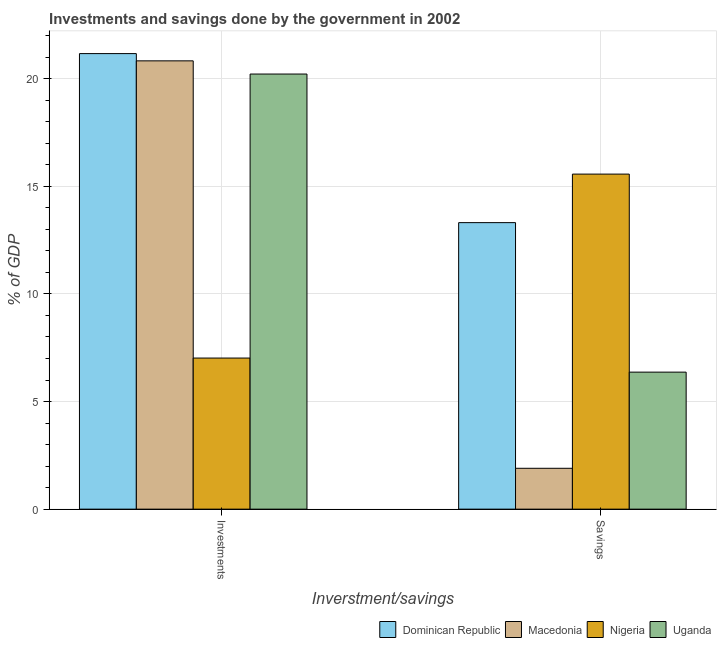How many different coloured bars are there?
Your response must be concise. 4. How many groups of bars are there?
Your answer should be compact. 2. Are the number of bars per tick equal to the number of legend labels?
Make the answer very short. Yes. How many bars are there on the 2nd tick from the right?
Provide a succinct answer. 4. What is the label of the 1st group of bars from the left?
Give a very brief answer. Investments. What is the investments of government in Dominican Republic?
Your response must be concise. 21.17. Across all countries, what is the maximum investments of government?
Make the answer very short. 21.17. Across all countries, what is the minimum investments of government?
Keep it short and to the point. 7.02. In which country was the savings of government maximum?
Your response must be concise. Nigeria. In which country was the savings of government minimum?
Keep it short and to the point. Macedonia. What is the total investments of government in the graph?
Keep it short and to the point. 69.24. What is the difference between the savings of government in Nigeria and that in Uganda?
Give a very brief answer. 9.2. What is the difference between the savings of government in Nigeria and the investments of government in Macedonia?
Provide a succinct answer. -5.26. What is the average investments of government per country?
Your response must be concise. 17.31. What is the difference between the savings of government and investments of government in Uganda?
Provide a short and direct response. -13.85. What is the ratio of the investments of government in Dominican Republic to that in Macedonia?
Give a very brief answer. 1.02. Is the savings of government in Macedonia less than that in Uganda?
Your answer should be compact. Yes. What does the 3rd bar from the left in Savings represents?
Your answer should be very brief. Nigeria. What does the 2nd bar from the right in Savings represents?
Your response must be concise. Nigeria. Are the values on the major ticks of Y-axis written in scientific E-notation?
Offer a terse response. No. What is the title of the graph?
Your response must be concise. Investments and savings done by the government in 2002. What is the label or title of the X-axis?
Your response must be concise. Inverstment/savings. What is the label or title of the Y-axis?
Ensure brevity in your answer.  % of GDP. What is the % of GDP in Dominican Republic in Investments?
Offer a terse response. 21.17. What is the % of GDP of Macedonia in Investments?
Provide a succinct answer. 20.83. What is the % of GDP in Nigeria in Investments?
Your answer should be compact. 7.02. What is the % of GDP of Uganda in Investments?
Provide a short and direct response. 20.22. What is the % of GDP of Dominican Republic in Savings?
Your response must be concise. 13.31. What is the % of GDP in Macedonia in Savings?
Keep it short and to the point. 1.9. What is the % of GDP of Nigeria in Savings?
Your answer should be compact. 15.57. What is the % of GDP of Uganda in Savings?
Make the answer very short. 6.37. Across all Inverstment/savings, what is the maximum % of GDP of Dominican Republic?
Ensure brevity in your answer.  21.17. Across all Inverstment/savings, what is the maximum % of GDP in Macedonia?
Your answer should be very brief. 20.83. Across all Inverstment/savings, what is the maximum % of GDP of Nigeria?
Your response must be concise. 15.57. Across all Inverstment/savings, what is the maximum % of GDP in Uganda?
Make the answer very short. 20.22. Across all Inverstment/savings, what is the minimum % of GDP in Dominican Republic?
Your answer should be compact. 13.31. Across all Inverstment/savings, what is the minimum % of GDP in Macedonia?
Your answer should be compact. 1.9. Across all Inverstment/savings, what is the minimum % of GDP in Nigeria?
Your answer should be very brief. 7.02. Across all Inverstment/savings, what is the minimum % of GDP in Uganda?
Provide a short and direct response. 6.37. What is the total % of GDP of Dominican Republic in the graph?
Offer a very short reply. 34.48. What is the total % of GDP of Macedonia in the graph?
Provide a succinct answer. 22.73. What is the total % of GDP of Nigeria in the graph?
Your response must be concise. 22.59. What is the total % of GDP of Uganda in the graph?
Offer a very short reply. 26.58. What is the difference between the % of GDP in Dominican Republic in Investments and that in Savings?
Make the answer very short. 7.85. What is the difference between the % of GDP of Macedonia in Investments and that in Savings?
Offer a very short reply. 18.93. What is the difference between the % of GDP of Nigeria in Investments and that in Savings?
Provide a short and direct response. -8.55. What is the difference between the % of GDP in Uganda in Investments and that in Savings?
Give a very brief answer. 13.85. What is the difference between the % of GDP in Dominican Republic in Investments and the % of GDP in Macedonia in Savings?
Give a very brief answer. 19.27. What is the difference between the % of GDP in Dominican Republic in Investments and the % of GDP in Nigeria in Savings?
Offer a terse response. 5.6. What is the difference between the % of GDP in Dominican Republic in Investments and the % of GDP in Uganda in Savings?
Make the answer very short. 14.8. What is the difference between the % of GDP in Macedonia in Investments and the % of GDP in Nigeria in Savings?
Provide a succinct answer. 5.26. What is the difference between the % of GDP of Macedonia in Investments and the % of GDP of Uganda in Savings?
Your answer should be compact. 14.46. What is the difference between the % of GDP in Nigeria in Investments and the % of GDP in Uganda in Savings?
Keep it short and to the point. 0.65. What is the average % of GDP in Dominican Republic per Inverstment/savings?
Offer a very short reply. 17.24. What is the average % of GDP in Macedonia per Inverstment/savings?
Your answer should be compact. 11.36. What is the average % of GDP in Nigeria per Inverstment/savings?
Your answer should be very brief. 11.29. What is the average % of GDP of Uganda per Inverstment/savings?
Your answer should be compact. 13.29. What is the difference between the % of GDP of Dominican Republic and % of GDP of Macedonia in Investments?
Your answer should be compact. 0.34. What is the difference between the % of GDP of Dominican Republic and % of GDP of Nigeria in Investments?
Provide a short and direct response. 14.15. What is the difference between the % of GDP of Dominican Republic and % of GDP of Uganda in Investments?
Offer a very short reply. 0.95. What is the difference between the % of GDP in Macedonia and % of GDP in Nigeria in Investments?
Your answer should be very brief. 13.81. What is the difference between the % of GDP in Macedonia and % of GDP in Uganda in Investments?
Your answer should be compact. 0.61. What is the difference between the % of GDP of Nigeria and % of GDP of Uganda in Investments?
Your answer should be very brief. -13.2. What is the difference between the % of GDP in Dominican Republic and % of GDP in Macedonia in Savings?
Offer a terse response. 11.41. What is the difference between the % of GDP of Dominican Republic and % of GDP of Nigeria in Savings?
Give a very brief answer. -2.26. What is the difference between the % of GDP in Dominican Republic and % of GDP in Uganda in Savings?
Provide a short and direct response. 6.95. What is the difference between the % of GDP in Macedonia and % of GDP in Nigeria in Savings?
Ensure brevity in your answer.  -13.67. What is the difference between the % of GDP of Macedonia and % of GDP of Uganda in Savings?
Offer a terse response. -4.47. What is the difference between the % of GDP in Nigeria and % of GDP in Uganda in Savings?
Give a very brief answer. 9.2. What is the ratio of the % of GDP in Dominican Republic in Investments to that in Savings?
Your answer should be compact. 1.59. What is the ratio of the % of GDP of Macedonia in Investments to that in Savings?
Your answer should be compact. 10.97. What is the ratio of the % of GDP of Nigeria in Investments to that in Savings?
Ensure brevity in your answer.  0.45. What is the ratio of the % of GDP in Uganda in Investments to that in Savings?
Your answer should be very brief. 3.18. What is the difference between the highest and the second highest % of GDP of Dominican Republic?
Keep it short and to the point. 7.85. What is the difference between the highest and the second highest % of GDP in Macedonia?
Keep it short and to the point. 18.93. What is the difference between the highest and the second highest % of GDP of Nigeria?
Your answer should be very brief. 8.55. What is the difference between the highest and the second highest % of GDP of Uganda?
Offer a very short reply. 13.85. What is the difference between the highest and the lowest % of GDP in Dominican Republic?
Provide a succinct answer. 7.85. What is the difference between the highest and the lowest % of GDP in Macedonia?
Offer a very short reply. 18.93. What is the difference between the highest and the lowest % of GDP in Nigeria?
Offer a very short reply. 8.55. What is the difference between the highest and the lowest % of GDP of Uganda?
Make the answer very short. 13.85. 